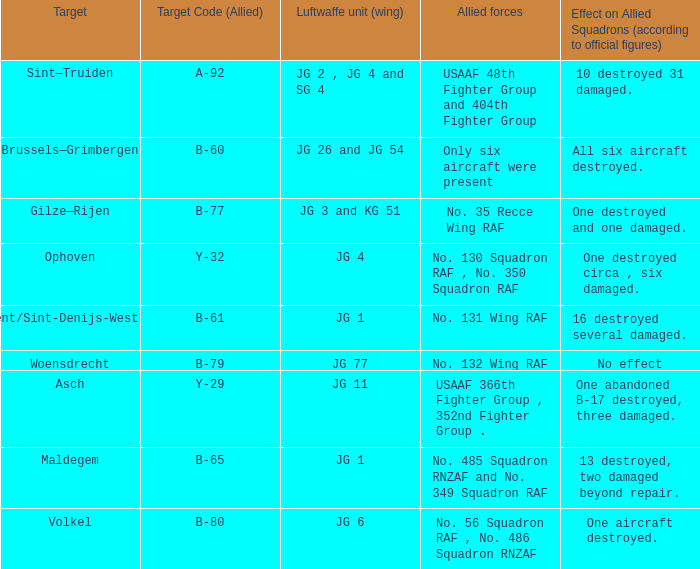What is the allied target code of the group that targetted ghent/sint-denijs-westrem? B-61. 